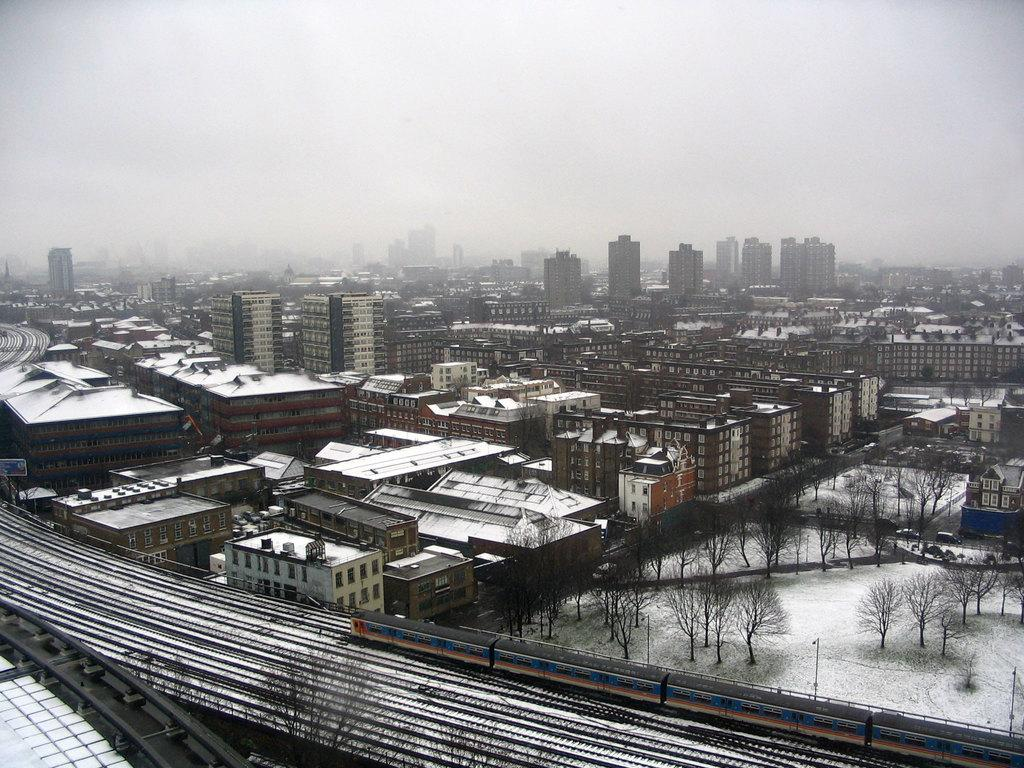What is the condition of the buildings in the image? The buildings in the image are covered with snow. What type of vegetation can be seen on the right side of the image? There are green trees on the right side of the image. How would you describe the sky in the image? The sky is foggy in the image. What is the temper of the liquid in the image? There is no liquid present in the image, so it is not possible to determine its temper. 